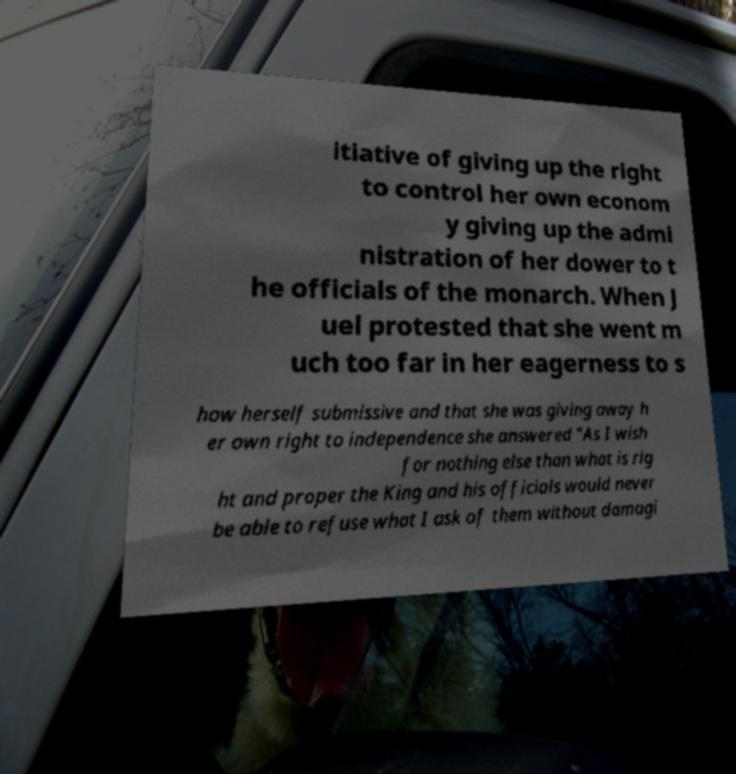Can you accurately transcribe the text from the provided image for me? itiative of giving up the right to control her own econom y giving up the admi nistration of her dower to t he officials of the monarch. When J uel protested that she went m uch too far in her eagerness to s how herself submissive and that she was giving away h er own right to independence she answered "As I wish for nothing else than what is rig ht and proper the King and his officials would never be able to refuse what I ask of them without damagi 